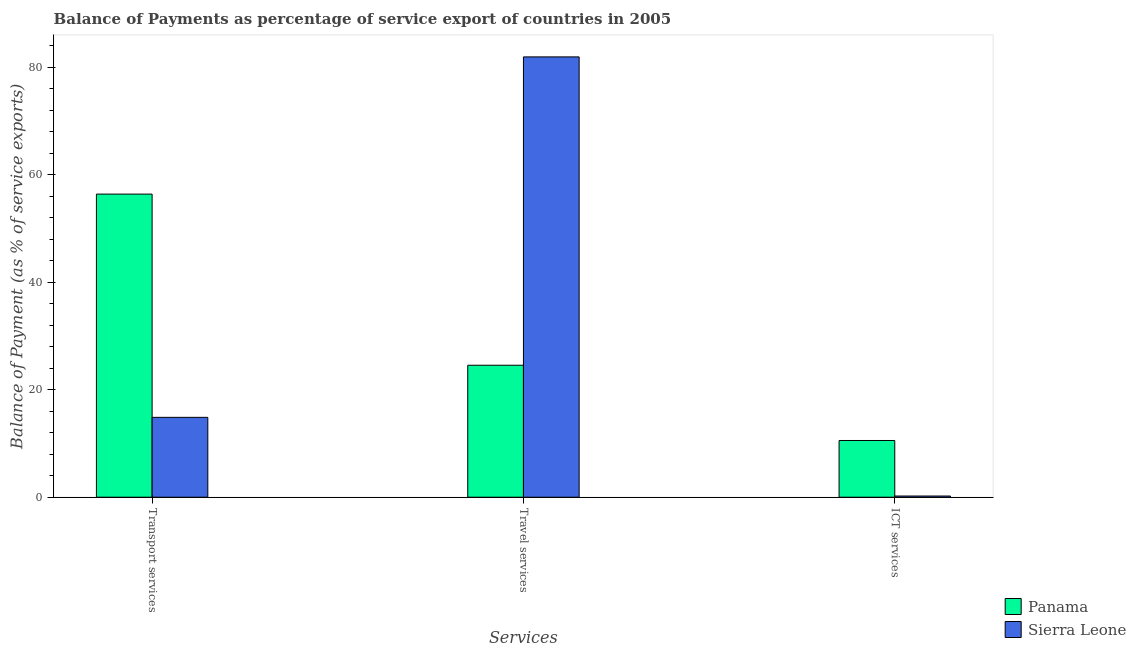How many different coloured bars are there?
Ensure brevity in your answer.  2. How many groups of bars are there?
Make the answer very short. 3. How many bars are there on the 3rd tick from the left?
Your answer should be compact. 2. How many bars are there on the 3rd tick from the right?
Your answer should be compact. 2. What is the label of the 2nd group of bars from the left?
Ensure brevity in your answer.  Travel services. What is the balance of payment of travel services in Sierra Leone?
Your response must be concise. 81.94. Across all countries, what is the maximum balance of payment of ict services?
Provide a short and direct response. 10.56. Across all countries, what is the minimum balance of payment of travel services?
Your response must be concise. 24.56. In which country was the balance of payment of travel services maximum?
Your answer should be very brief. Sierra Leone. In which country was the balance of payment of transport services minimum?
Provide a succinct answer. Sierra Leone. What is the total balance of payment of transport services in the graph?
Provide a succinct answer. 71.27. What is the difference between the balance of payment of ict services in Sierra Leone and that in Panama?
Provide a short and direct response. -10.34. What is the difference between the balance of payment of travel services in Panama and the balance of payment of ict services in Sierra Leone?
Make the answer very short. 24.34. What is the average balance of payment of travel services per country?
Ensure brevity in your answer.  53.25. What is the difference between the balance of payment of travel services and balance of payment of ict services in Sierra Leone?
Provide a short and direct response. 81.72. In how many countries, is the balance of payment of ict services greater than 76 %?
Make the answer very short. 0. What is the ratio of the balance of payment of transport services in Panama to that in Sierra Leone?
Your response must be concise. 3.8. Is the balance of payment of transport services in Panama less than that in Sierra Leone?
Ensure brevity in your answer.  No. Is the difference between the balance of payment of transport services in Panama and Sierra Leone greater than the difference between the balance of payment of travel services in Panama and Sierra Leone?
Your answer should be very brief. Yes. What is the difference between the highest and the second highest balance of payment of transport services?
Make the answer very short. 41.55. What is the difference between the highest and the lowest balance of payment of ict services?
Ensure brevity in your answer.  10.34. In how many countries, is the balance of payment of transport services greater than the average balance of payment of transport services taken over all countries?
Provide a succinct answer. 1. What does the 1st bar from the left in Travel services represents?
Provide a short and direct response. Panama. What does the 2nd bar from the right in Travel services represents?
Offer a very short reply. Panama. How many bars are there?
Offer a very short reply. 6. How many countries are there in the graph?
Your response must be concise. 2. What is the difference between two consecutive major ticks on the Y-axis?
Your answer should be compact. 20. Are the values on the major ticks of Y-axis written in scientific E-notation?
Ensure brevity in your answer.  No. Does the graph contain any zero values?
Offer a very short reply. No. Does the graph contain grids?
Keep it short and to the point. No. Where does the legend appear in the graph?
Ensure brevity in your answer.  Bottom right. How many legend labels are there?
Give a very brief answer. 2. What is the title of the graph?
Ensure brevity in your answer.  Balance of Payments as percentage of service export of countries in 2005. Does "Serbia" appear as one of the legend labels in the graph?
Provide a short and direct response. No. What is the label or title of the X-axis?
Ensure brevity in your answer.  Services. What is the label or title of the Y-axis?
Make the answer very short. Balance of Payment (as % of service exports). What is the Balance of Payment (as % of service exports) in Panama in Transport services?
Your response must be concise. 56.41. What is the Balance of Payment (as % of service exports) in Sierra Leone in Transport services?
Provide a short and direct response. 14.86. What is the Balance of Payment (as % of service exports) in Panama in Travel services?
Offer a very short reply. 24.56. What is the Balance of Payment (as % of service exports) in Sierra Leone in Travel services?
Your answer should be very brief. 81.94. What is the Balance of Payment (as % of service exports) in Panama in ICT services?
Ensure brevity in your answer.  10.56. What is the Balance of Payment (as % of service exports) of Sierra Leone in ICT services?
Make the answer very short. 0.22. Across all Services, what is the maximum Balance of Payment (as % of service exports) in Panama?
Provide a short and direct response. 56.41. Across all Services, what is the maximum Balance of Payment (as % of service exports) in Sierra Leone?
Ensure brevity in your answer.  81.94. Across all Services, what is the minimum Balance of Payment (as % of service exports) of Panama?
Offer a terse response. 10.56. Across all Services, what is the minimum Balance of Payment (as % of service exports) in Sierra Leone?
Your response must be concise. 0.22. What is the total Balance of Payment (as % of service exports) in Panama in the graph?
Your answer should be very brief. 91.52. What is the total Balance of Payment (as % of service exports) in Sierra Leone in the graph?
Ensure brevity in your answer.  97.02. What is the difference between the Balance of Payment (as % of service exports) in Panama in Transport services and that in Travel services?
Make the answer very short. 31.85. What is the difference between the Balance of Payment (as % of service exports) in Sierra Leone in Transport services and that in Travel services?
Ensure brevity in your answer.  -67.08. What is the difference between the Balance of Payment (as % of service exports) of Panama in Transport services and that in ICT services?
Your answer should be compact. 45.85. What is the difference between the Balance of Payment (as % of service exports) of Sierra Leone in Transport services and that in ICT services?
Keep it short and to the point. 14.64. What is the difference between the Balance of Payment (as % of service exports) of Panama in Travel services and that in ICT services?
Provide a succinct answer. 14. What is the difference between the Balance of Payment (as % of service exports) in Sierra Leone in Travel services and that in ICT services?
Provide a succinct answer. 81.72. What is the difference between the Balance of Payment (as % of service exports) of Panama in Transport services and the Balance of Payment (as % of service exports) of Sierra Leone in Travel services?
Your answer should be very brief. -25.53. What is the difference between the Balance of Payment (as % of service exports) of Panama in Transport services and the Balance of Payment (as % of service exports) of Sierra Leone in ICT services?
Provide a succinct answer. 56.19. What is the difference between the Balance of Payment (as % of service exports) in Panama in Travel services and the Balance of Payment (as % of service exports) in Sierra Leone in ICT services?
Provide a succinct answer. 24.34. What is the average Balance of Payment (as % of service exports) of Panama per Services?
Make the answer very short. 30.51. What is the average Balance of Payment (as % of service exports) of Sierra Leone per Services?
Your answer should be very brief. 32.34. What is the difference between the Balance of Payment (as % of service exports) of Panama and Balance of Payment (as % of service exports) of Sierra Leone in Transport services?
Ensure brevity in your answer.  41.55. What is the difference between the Balance of Payment (as % of service exports) in Panama and Balance of Payment (as % of service exports) in Sierra Leone in Travel services?
Offer a terse response. -57.38. What is the difference between the Balance of Payment (as % of service exports) in Panama and Balance of Payment (as % of service exports) in Sierra Leone in ICT services?
Your answer should be compact. 10.34. What is the ratio of the Balance of Payment (as % of service exports) of Panama in Transport services to that in Travel services?
Ensure brevity in your answer.  2.3. What is the ratio of the Balance of Payment (as % of service exports) of Sierra Leone in Transport services to that in Travel services?
Offer a very short reply. 0.18. What is the ratio of the Balance of Payment (as % of service exports) in Panama in Transport services to that in ICT services?
Your response must be concise. 5.34. What is the ratio of the Balance of Payment (as % of service exports) of Sierra Leone in Transport services to that in ICT services?
Give a very brief answer. 67.12. What is the ratio of the Balance of Payment (as % of service exports) in Panama in Travel services to that in ICT services?
Keep it short and to the point. 2.33. What is the ratio of the Balance of Payment (as % of service exports) in Sierra Leone in Travel services to that in ICT services?
Ensure brevity in your answer.  370.08. What is the difference between the highest and the second highest Balance of Payment (as % of service exports) in Panama?
Make the answer very short. 31.85. What is the difference between the highest and the second highest Balance of Payment (as % of service exports) of Sierra Leone?
Give a very brief answer. 67.08. What is the difference between the highest and the lowest Balance of Payment (as % of service exports) in Panama?
Your answer should be very brief. 45.85. What is the difference between the highest and the lowest Balance of Payment (as % of service exports) of Sierra Leone?
Keep it short and to the point. 81.72. 